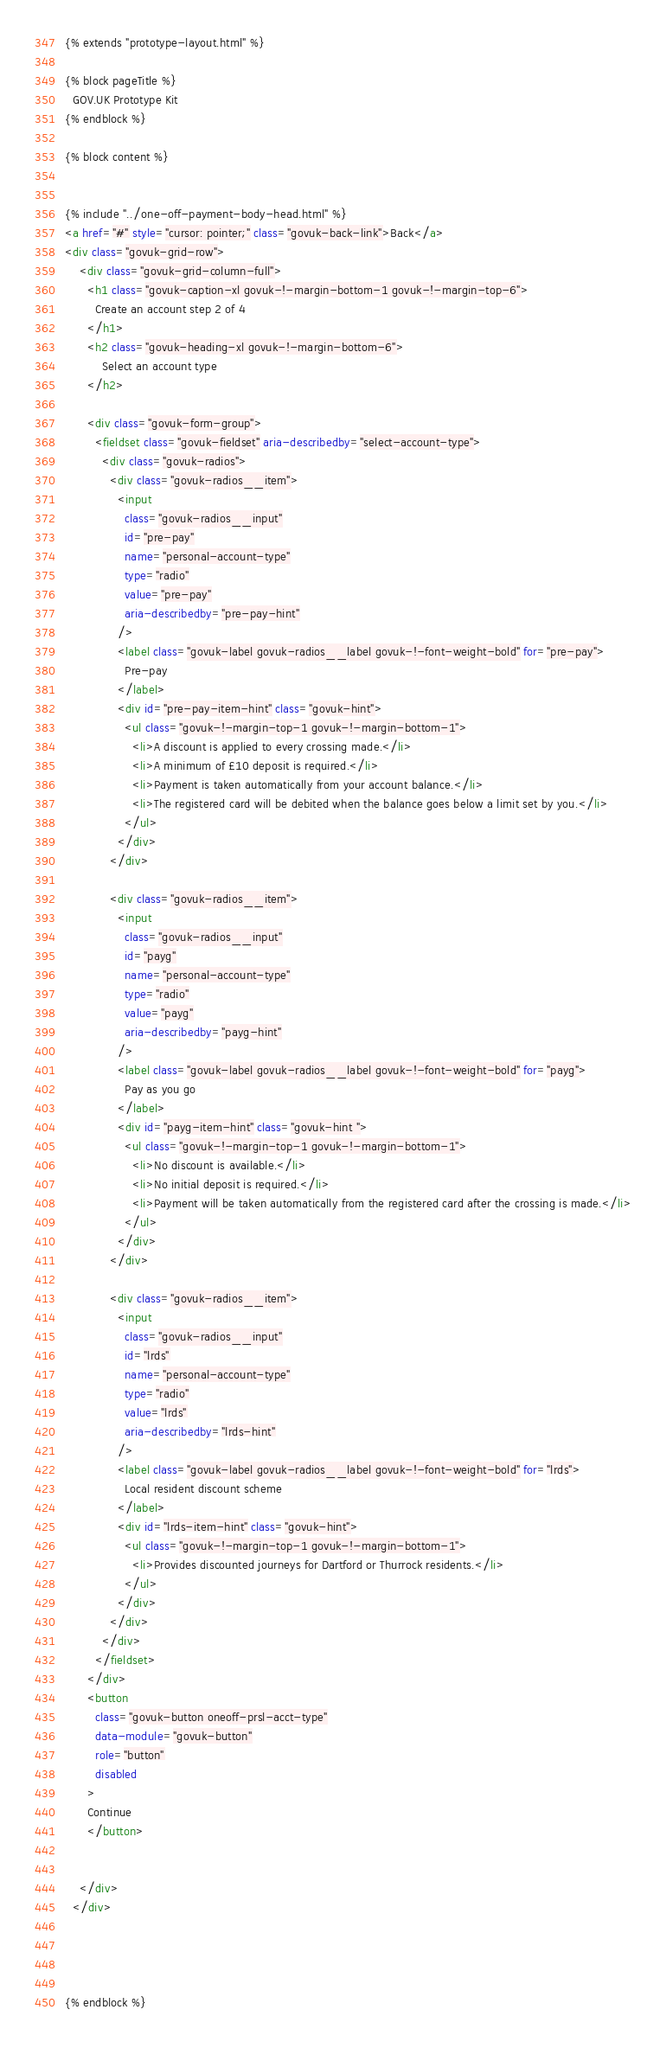<code> <loc_0><loc_0><loc_500><loc_500><_HTML_>{% extends "prototype-layout.html" %}

{% block pageTitle %}
  GOV.UK Prototype Kit
{% endblock %}

{% block content %}


{% include "../one-off-payment-body-head.html" %}
<a href="#" style="cursor: pointer;" class="govuk-back-link">Back</a> 
<div class="govuk-grid-row">
    <div class="govuk-grid-column-full">
      <h1 class="govuk-caption-xl govuk-!-margin-bottom-1 govuk-!-margin-top-6">
        Create an account step 2 of 4
      </h1>
      <h2 class="govuk-heading-xl govuk-!-margin-bottom-6">
          Select an account type
      </h2>

      <div class="govuk-form-group">
        <fieldset class="govuk-fieldset" aria-describedby="select-account-type">
          <div class="govuk-radios">
            <div class="govuk-radios__item">
              <input
                class="govuk-radios__input"
                id="pre-pay"
                name="personal-account-type"
                type="radio"
                value="pre-pay"
                aria-describedby="pre-pay-hint"
              />
              <label class="govuk-label govuk-radios__label govuk-!-font-weight-bold" for="pre-pay">
                Pre-pay
              </label>
              <div id="pre-pay-item-hint" class="govuk-hint">
                <ul class="govuk-!-margin-top-1 govuk-!-margin-bottom-1">
                  <li>A discount is applied to every crossing made.</li>
                  <li>A minimum of £10 deposit is required.</li>
                  <li>Payment is taken automatically from your account balance.</li>
                  <li>The registered card will be debited when the balance goes below a limit set by you.</li>
                </ul>
              </div>
            </div>
  
            <div class="govuk-radios__item">
              <input
                class="govuk-radios__input"
                id="payg"
                name="personal-account-type"
                type="radio"
                value="payg"
                aria-describedby="payg-hint"
              />
              <label class="govuk-label govuk-radios__label govuk-!-font-weight-bold" for="payg">
                Pay as you go
              </label>
              <div id="payg-item-hint" class="govuk-hint ">
                <ul class="govuk-!-margin-top-1 govuk-!-margin-bottom-1">
                  <li>No discount is available.</li>
                  <li>No initial deposit is required.</li>
                  <li>Payment will be taken automatically from the registered card after the crossing is made.</li>
                </ul>
              </div>
            </div>
  
            <div class="govuk-radios__item">
              <input
                class="govuk-radios__input"
                id="lrds"
                name="personal-account-type"
                type="radio"
                value="lrds"
                aria-describedby="lrds-hint"
              />
              <label class="govuk-label govuk-radios__label govuk-!-font-weight-bold" for="lrds">
                Local resident discount scheme
              </label>
              <div id="lrds-item-hint" class="govuk-hint">
                <ul class="govuk-!-margin-top-1 govuk-!-margin-bottom-1">
                  <li>Provides discounted journeys for Dartford or Thurrock residents.</li>
                </ul>
              </div>
            </div>
          </div>
        </fieldset>
      </div>
      <button
        class="govuk-button oneoff-prsl-acct-type"
        data-module="govuk-button"
        role="button"
        disabled
      >
      Continue
      </button>


    </div>
  </div>




{% endblock %}</code> 